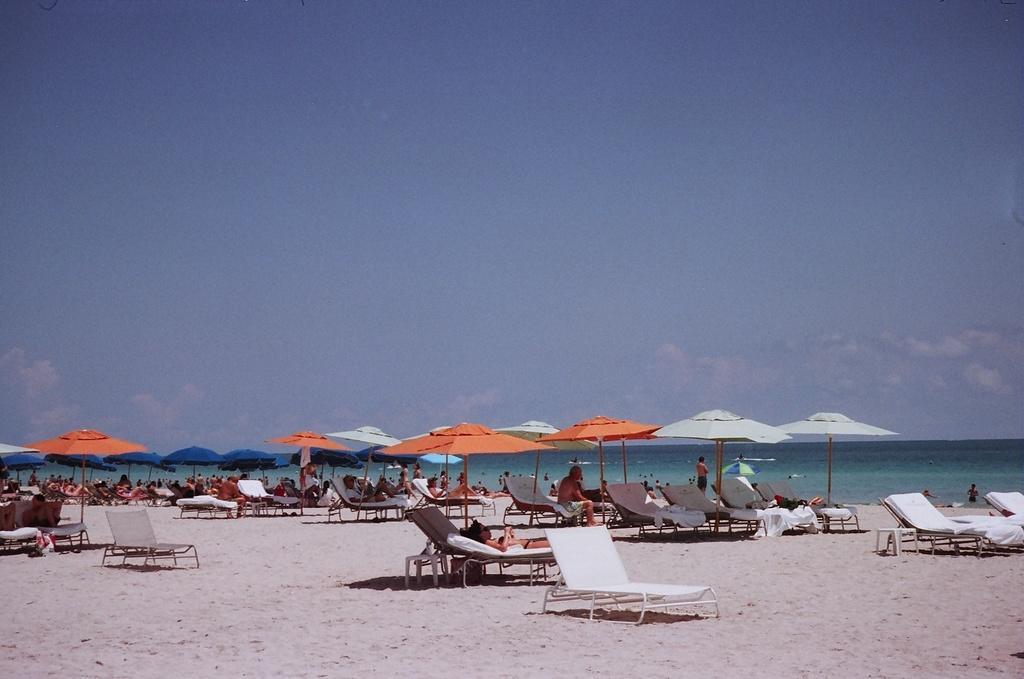Please provide a concise description of this image. In this picture we can see there are groups of people, beach umbrellas, sand and chairs. Behind the people, there is the sea and the sky. 